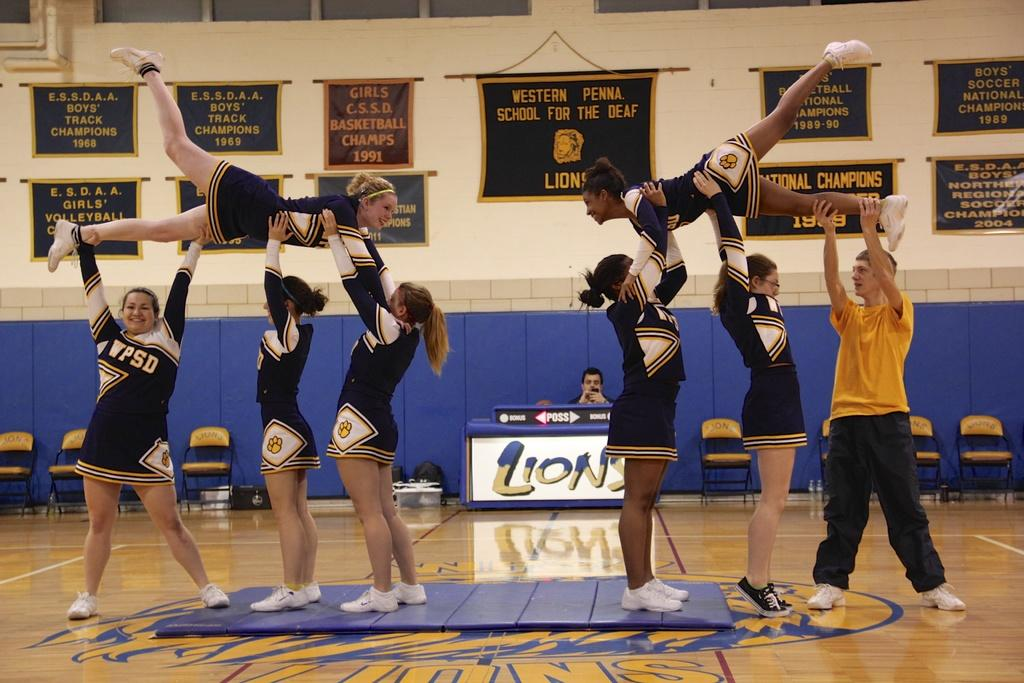Provide a one-sentence caption for the provided image. Cheerleaders from WPDS are performing pyramid stunts in a gym. 